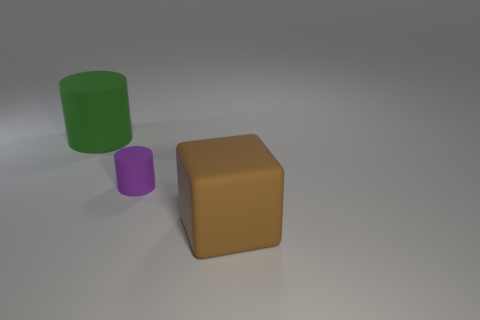Add 3 tiny brown things. How many objects exist? 6 Subtract all cylinders. How many objects are left? 1 Add 1 small cylinders. How many small cylinders are left? 2 Add 3 cylinders. How many cylinders exist? 5 Subtract 0 blue blocks. How many objects are left? 3 Subtract all big brown rubber cubes. Subtract all big cubes. How many objects are left? 1 